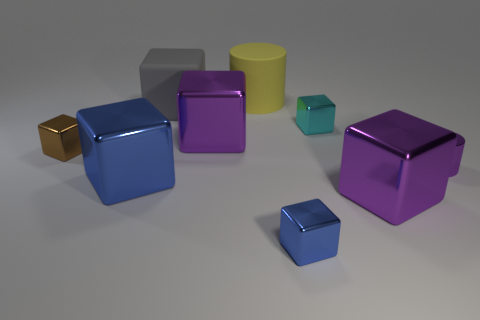Add 1 green cylinders. How many objects exist? 10 Subtract all big blue shiny blocks. How many blocks are left? 6 Subtract all gray cylinders. How many blue cubes are left? 2 Subtract all brown blocks. How many blocks are left? 6 Subtract all cylinders. How many objects are left? 7 Subtract 6 cubes. How many cubes are left? 1 Subtract all yellow cylinders. Subtract all brown cubes. How many cylinders are left? 1 Subtract all small purple cylinders. Subtract all small blue blocks. How many objects are left? 7 Add 2 big matte things. How many big matte things are left? 4 Add 5 large cyan rubber objects. How many large cyan rubber objects exist? 5 